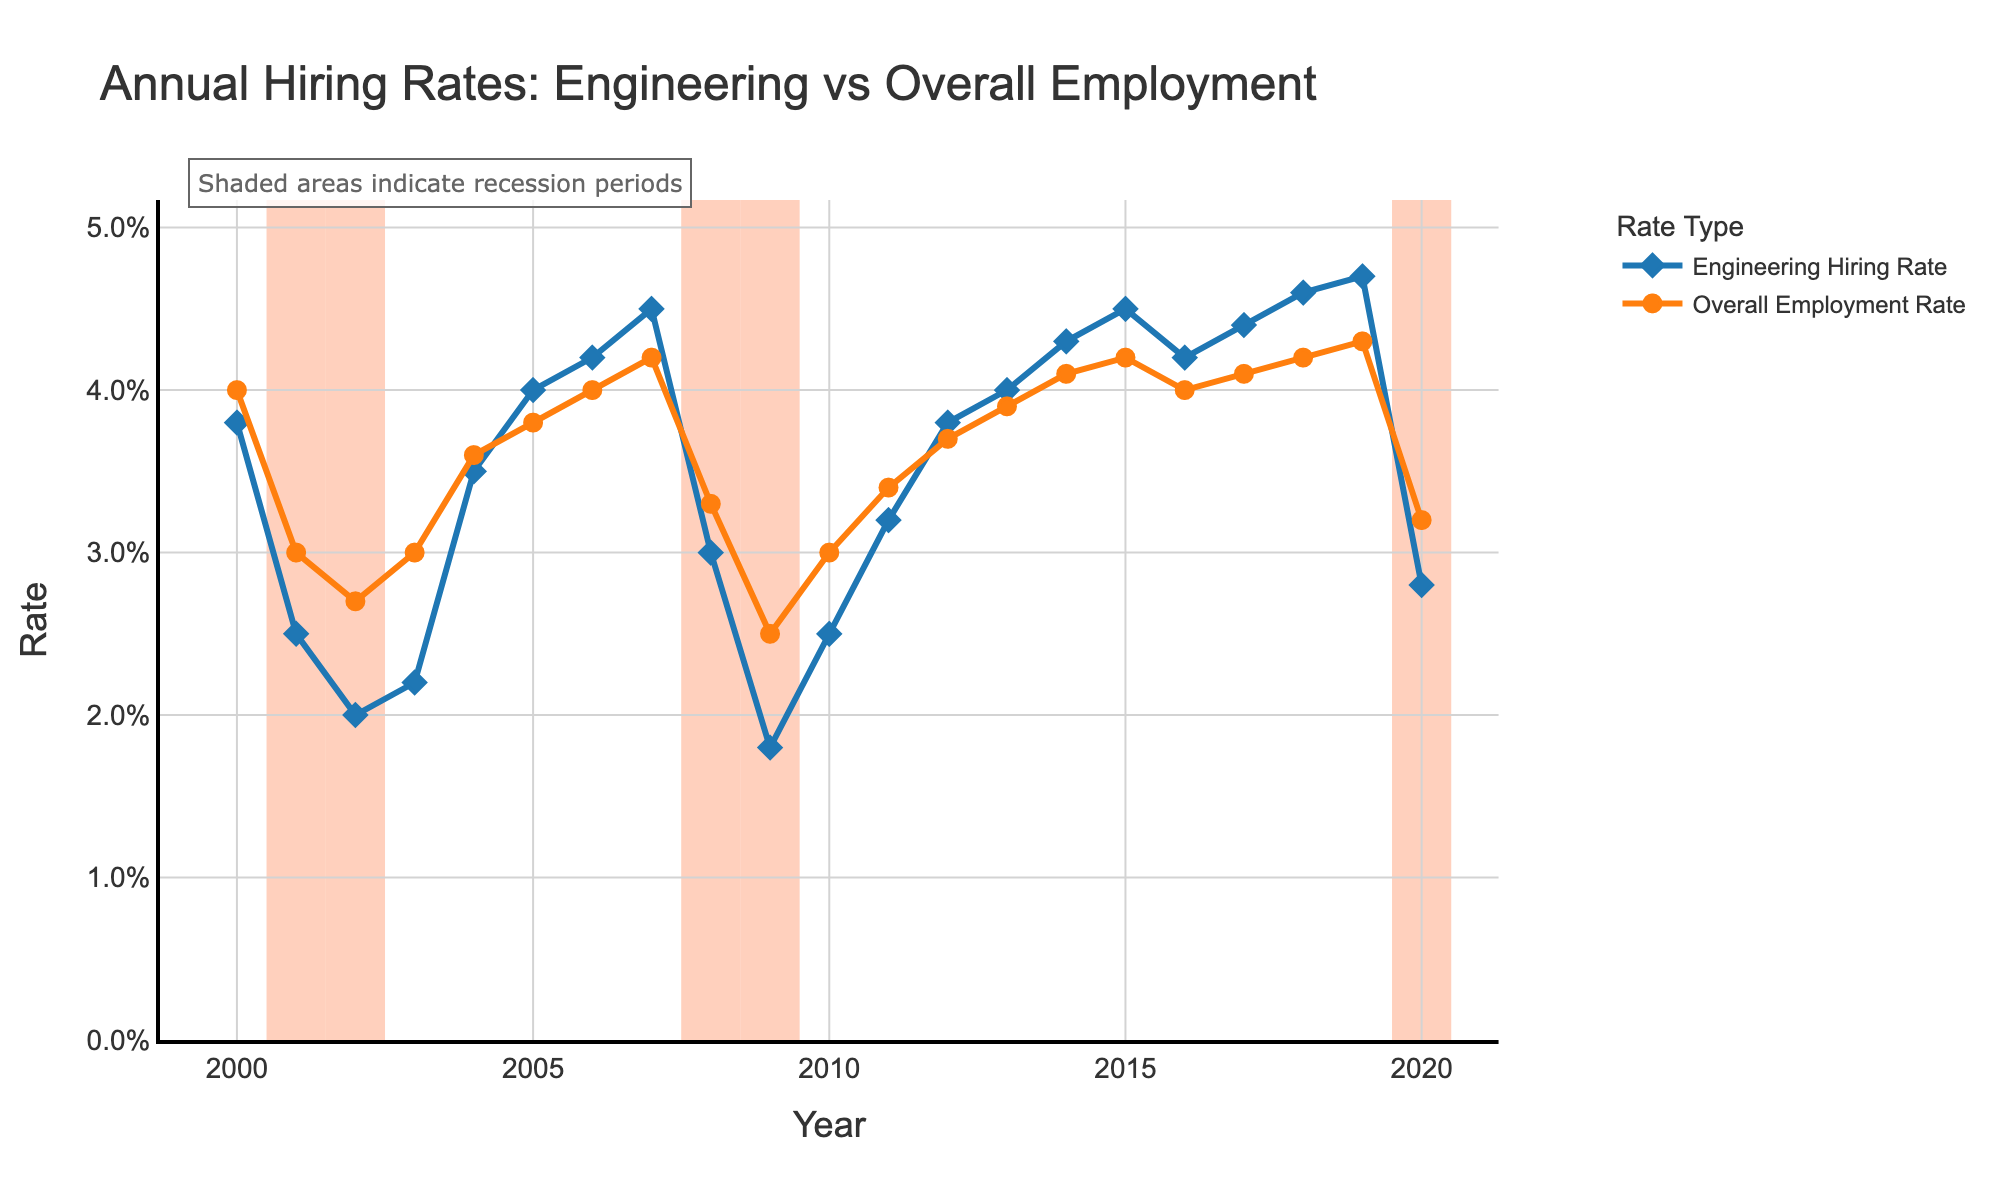When did the Engineering Hiring Rate first surpass the Overall Employment Rate after the 2001 recession? To answer this question, we need to look at the years following the 2001 recession, which ended in 2002, and identify when the blue line (Engineering Hiring Rate) is above the orange line (Overall Employment Rate). This occurs in 2004.
Answer: 2004 How did the Engineering Hiring Rate change from 2007 to 2009 during the recession period? The Engineering Hiring Rate in 2007 was 4.5%, in 2008 it dropped to 3.0%, and in 2009 it further decreased to 1.8%. Overall, there was a decrease of 2.7% from 2007 to 2009.
Answer: Decreased by 2.7% Comparing recession and non-recession periods, which period shows a higher average Engineering Hiring Rate? First, identify the average Engineering Hiring Rate during recession years (2001, 2002, 2008, 2009, 2020) and non-recession years. Average the rates for both periods and compare them. Recession rates: (2.5% + 2.0% + 3.0% + 1.8% + 2.8%)/5 = 2.42%. Non-recession rates for remaining years are higher.
Answer: Non-recession Which year had the highest Overall Employment Rate in non-recession periods? Identify years marked as "No" under Recession Period and find the highest value in the orange line (Overall Employment Rate). In this case, it happens in 2007 and 2019, both with rates of 4.3%.
Answer: 2007, 2019 During which recession period did the Engineering Hiring Rate experience the largest decline? Compare the drop in Engineering Hiring Rate across different recession years: 2001-2002, 2008-2009, and 2019-2020. The largest decline is from 2007 (4.5%) to 2009 (1.8%), indicating the 2008-2009 recession.
Answer: 2008-2009 What is the trend observed in the Overall Employment Rate from 2013 to 2015? To determine the trend, observe the orange line from 2013 (3.9%) to 2014 (4.1%) to 2015 (4.2%). The Overall Employment Rate shows an increasing trend over these years.
Answer: Increasing What's the average Engineering Hiring Rate during non-recession years from 2010 to 2019? Calculate the average for the rates from 2010 to 2019 excluding recession years. (2.5% + 3.2% + 3.8% + 4.0% + 4.3% + 4.5% + 4.2% + 4.4% + 4.6% + 4.7%)/10 = 4.02%
Answer: 4.02% Which year showed a decrease in both Engineering Hiring Rate and Overall Employment Rate? Identify years where both the blue and orange lines decrease from the previous year. This occurs in 2001, 2002, with both rates declining.
Answer: 2001, 2002 Do the Engineering Hiring Rates appear to recover to pre-recession levels after the 2008 recession? Compare the rates after 2008 recession (2009 to subsequent years) to pre-recession 2007 (4.5%). By 2012, the rates are consistently higher than the pre-recession level.
Answer: Yes What is the longest period without any recession where the Engineering Hiring Rate increases or stays stable year over year? Examine the years without recession (marked "No") where the blue line (Engineering Hiring Rate) consistently rises or remains the same. From 2010 (2.5%) to 2019 (4.7%), the Engineering Hiring Rate either increases or remains stable. This period lasts for 10 years.
Answer: 10 years 